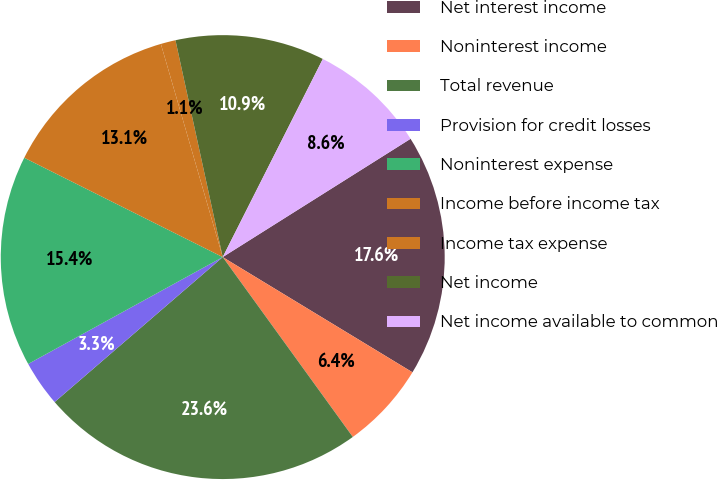Convert chart. <chart><loc_0><loc_0><loc_500><loc_500><pie_chart><fcel>Net interest income<fcel>Noninterest income<fcel>Total revenue<fcel>Provision for credit losses<fcel>Noninterest expense<fcel>Income before income tax<fcel>Income tax expense<fcel>Net income<fcel>Net income available to common<nl><fcel>17.63%<fcel>6.35%<fcel>23.64%<fcel>3.33%<fcel>15.38%<fcel>13.12%<fcel>1.08%<fcel>10.86%<fcel>8.61%<nl></chart> 